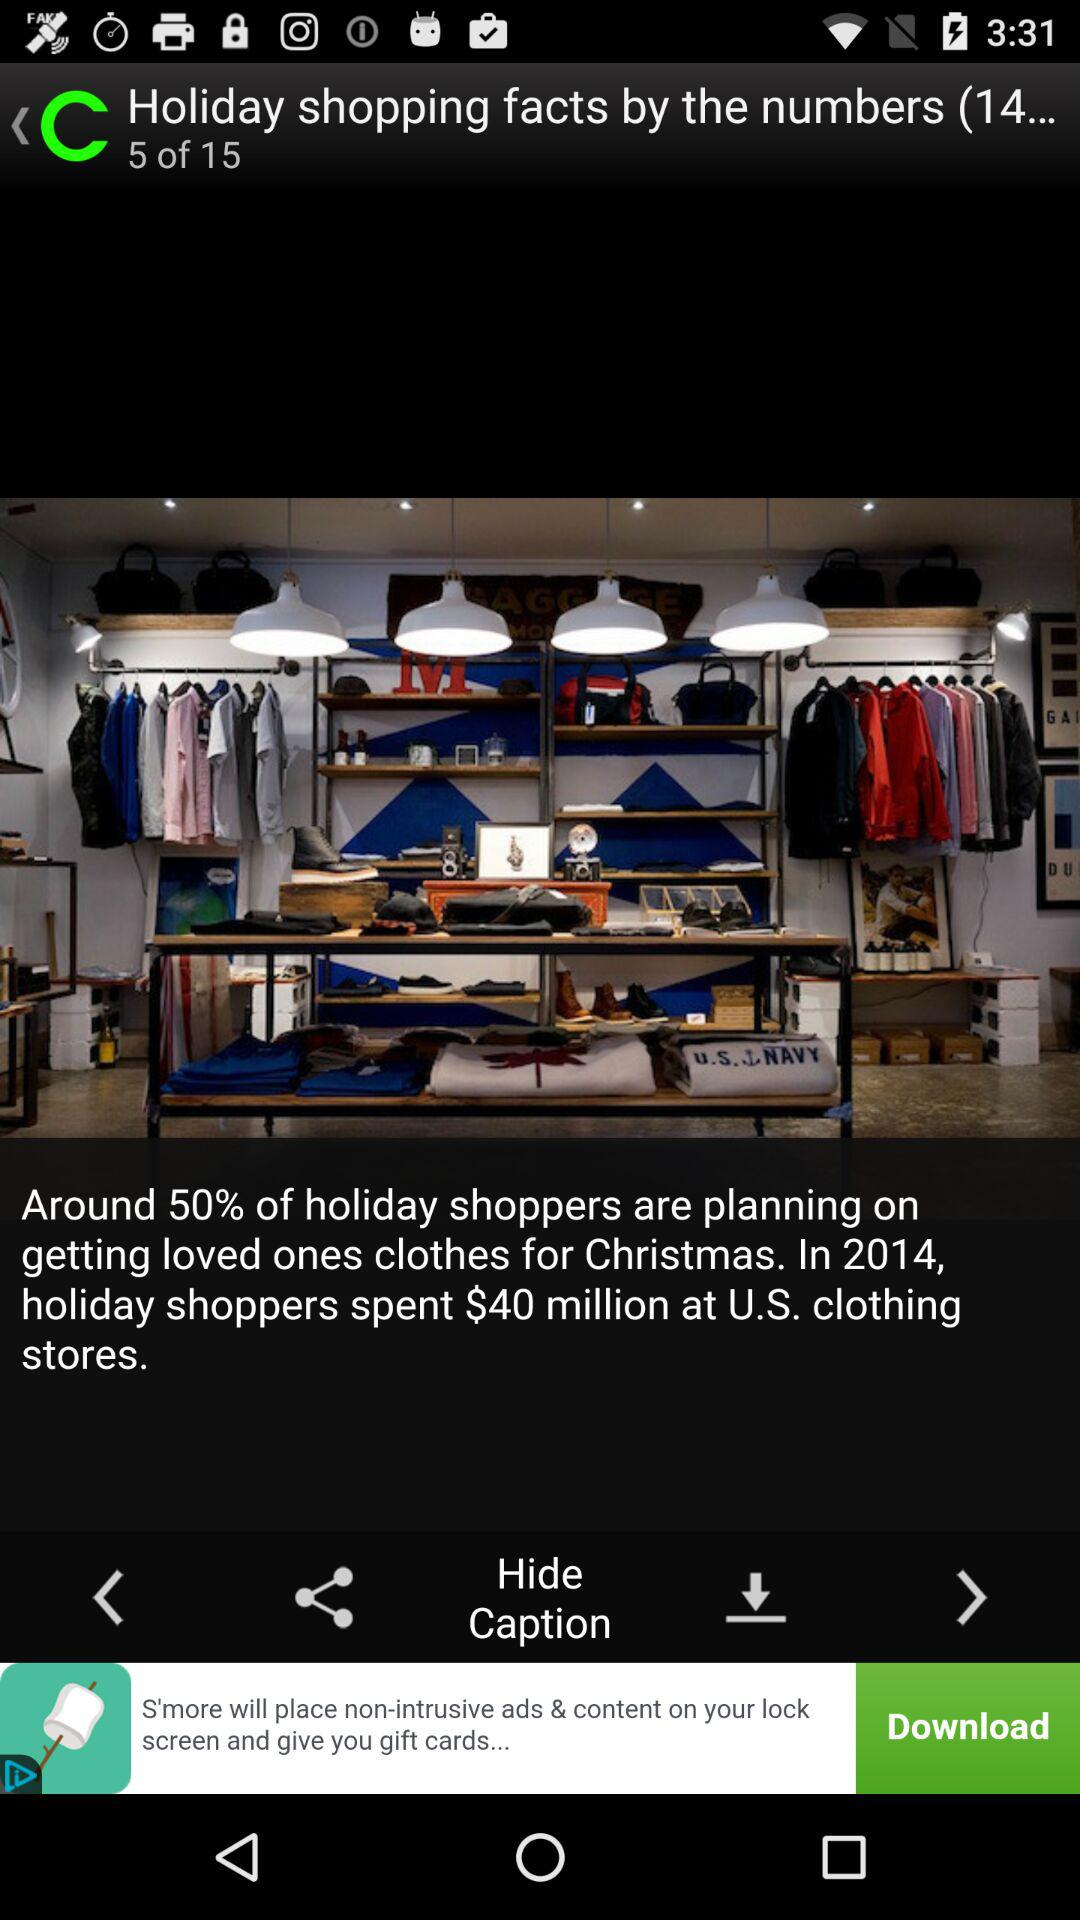How many more shopping facts are there after the one that mentions clothes?
Answer the question using a single word or phrase. 10 